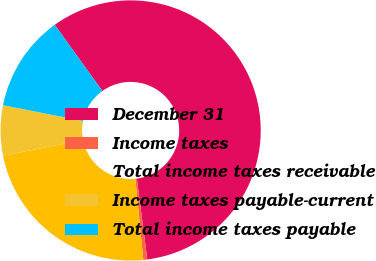<chart> <loc_0><loc_0><loc_500><loc_500><pie_chart><fcel>December 31<fcel>Income taxes<fcel>Total income taxes receivable<fcel>Income taxes payable-current<fcel>Total income taxes payable<nl><fcel>57.88%<fcel>0.49%<fcel>23.44%<fcel>6.23%<fcel>11.97%<nl></chart> 